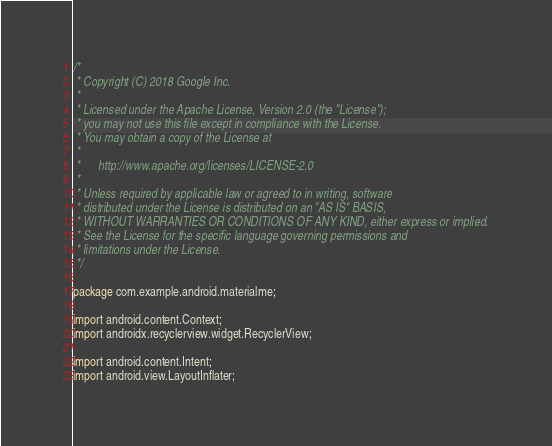<code> <loc_0><loc_0><loc_500><loc_500><_Java_>/*
 * Copyright (C) 2018 Google Inc.
 *
 * Licensed under the Apache License, Version 2.0 (the "License");
 * you may not use this file except in compliance with the License.
 * You may obtain a copy of the License at
 *
 *      http://www.apache.org/licenses/LICENSE-2.0
 *
 * Unless required by applicable law or agreed to in writing, software
 * distributed under the License is distributed on an "AS IS" BASIS,
 * WITHOUT WARRANTIES OR CONDITIONS OF ANY KIND, either express or implied.
 * See the License for the specific language governing permissions and
 * limitations under the License.
 */

package com.example.android.materialme;

import android.content.Context;
import androidx.recyclerview.widget.RecyclerView;

import android.content.Intent;
import android.view.LayoutInflater;</code> 